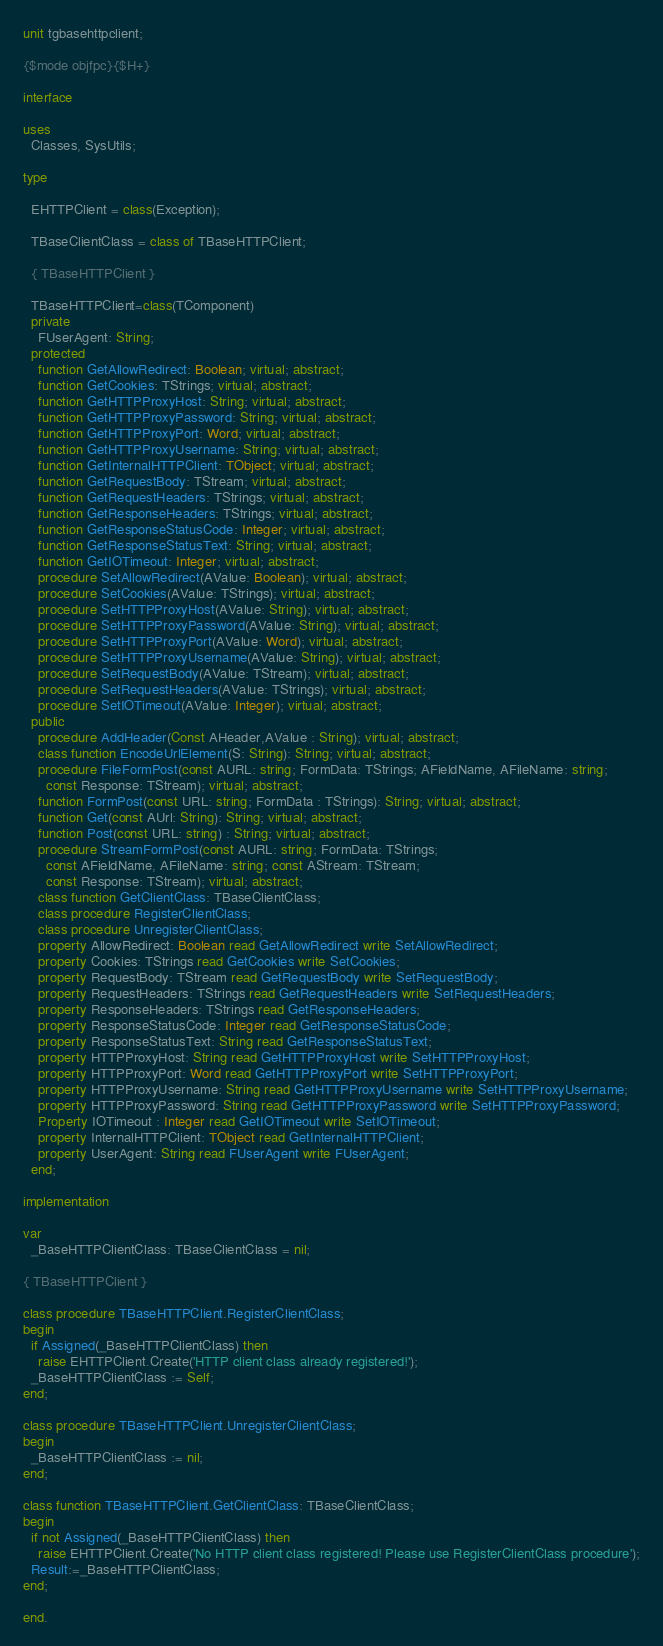<code> <loc_0><loc_0><loc_500><loc_500><_Pascal_>unit tgbasehttpclient;

{$mode objfpc}{$H+}

interface

uses
  Classes, SysUtils;

type

  EHTTPClient = class(Exception);

  TBaseClientClass = class of TBaseHTTPClient;

  { TBaseHTTPClient }

  TBaseHTTPClient=class(TComponent)
  private
    FUserAgent: String;
  protected
    function GetAllowRedirect: Boolean; virtual; abstract;
    function GetCookies: TStrings; virtual; abstract;
    function GetHTTPProxyHost: String; virtual; abstract;
    function GetHTTPProxyPassword: String; virtual; abstract;
    function GetHTTPProxyPort: Word; virtual; abstract;
    function GetHTTPProxyUsername: String; virtual; abstract;
    function GetInternalHTTPClient: TObject; virtual; abstract;
    function GetRequestBody: TStream; virtual; abstract;
    function GetRequestHeaders: TStrings; virtual; abstract;
    function GetResponseHeaders: TStrings; virtual; abstract;
    function GetResponseStatusCode: Integer; virtual; abstract;
    function GetResponseStatusText: String; virtual; abstract;
    function GetIOTimeout: Integer; virtual; abstract;
    procedure SetAllowRedirect(AValue: Boolean); virtual; abstract;
    procedure SetCookies(AValue: TStrings); virtual; abstract;
    procedure SetHTTPProxyHost(AValue: String); virtual; abstract;
    procedure SetHTTPProxyPassword(AValue: String); virtual; abstract;
    procedure SetHTTPProxyPort(AValue: Word); virtual; abstract;
    procedure SetHTTPProxyUsername(AValue: String); virtual; abstract;
    procedure SetRequestBody(AValue: TStream); virtual; abstract;
    procedure SetRequestHeaders(AValue: TStrings); virtual; abstract;
    procedure SetIOTimeout(AValue: Integer); virtual; abstract;
  public
    procedure AddHeader(Const AHeader,AValue : String); virtual; abstract;
    class function EncodeUrlElement(S: String): String; virtual; abstract;
    procedure FileFormPost(const AURL: string; FormData: TStrings; AFieldName, AFileName: string;
      const Response: TStream); virtual; abstract;
    function FormPost(const URL: string; FormData : TStrings): String; virtual; abstract;
    function Get(const AUrl: String): String; virtual; abstract;
    function Post(const URL: string) : String; virtual; abstract;
    procedure StreamFormPost(const AURL: string; FormData: TStrings;
      const AFieldName, AFileName: string; const AStream: TStream;
      const Response: TStream); virtual; abstract;
    class function GetClientClass: TBaseClientClass;
    class procedure RegisterClientClass;
    class procedure UnregisterClientClass;
    property AllowRedirect: Boolean read GetAllowRedirect write SetAllowRedirect;
    property Cookies: TStrings read GetCookies write SetCookies;
    property RequestBody: TStream read GetRequestBody write SetRequestBody;
    property RequestHeaders: TStrings read GetRequestHeaders write SetRequestHeaders;
    property ResponseHeaders: TStrings read GetResponseHeaders;
    property ResponseStatusCode: Integer read GetResponseStatusCode;
    property ResponseStatusText: String read GetResponseStatusText;
    property HTTPProxyHost: String read GetHTTPProxyHost write SetHTTPProxyHost;
    property HTTPProxyPort: Word read GetHTTPProxyPort write SetHTTPProxyPort;
    property HTTPProxyUsername: String read GetHTTPProxyUsername write SetHTTPProxyUsername;
    property HTTPProxyPassword: String read GetHTTPProxyPassword write SetHTTPProxyPassword;
    Property IOTimeout : Integer read GetIOTimeout write SetIOTimeout;
    property InternalHTTPClient: TObject read GetInternalHTTPClient;
    property UserAgent: String read FUserAgent write FUserAgent;
  end;

implementation

var
  _BaseHTTPClientClass: TBaseClientClass = nil;

{ TBaseHTTPClient }

class procedure TBaseHTTPClient.RegisterClientClass;
begin
  if Assigned(_BaseHTTPClientClass) then
    raise EHTTPClient.Create('HTTP client class already registered!');
  _BaseHTTPClientClass := Self;
end;

class procedure TBaseHTTPClient.UnregisterClientClass;
begin
  _BaseHTTPClientClass := nil;
end;

class function TBaseHTTPClient.GetClientClass: TBaseClientClass;
begin
  if not Assigned(_BaseHTTPClientClass) then
    raise EHTTPClient.Create('No HTTP client class registered! Please use RegisterClientClass procedure');
  Result:=_BaseHTTPClientClass;
end;

end.

</code> 